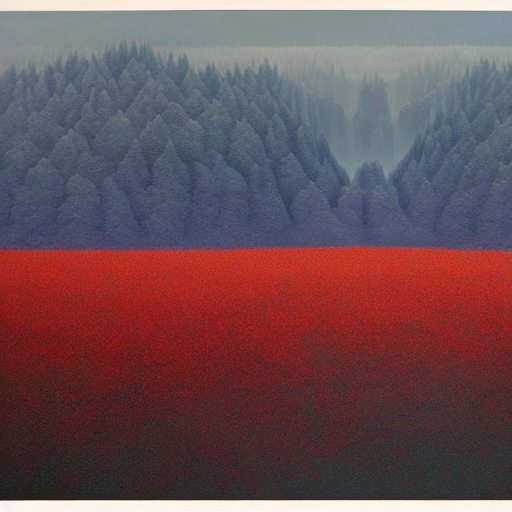Is the red color in the foreground natural, or has the photograph been edited for artistic effect? While there are certainly naturally occurring red fields, such as those of poppy flowers or certain crops, the saturation and uniformity of the red here might suggest that the photograph has been edited to enhance the visual impact, creating a stark contrast with the blue and green hues of the forest. 